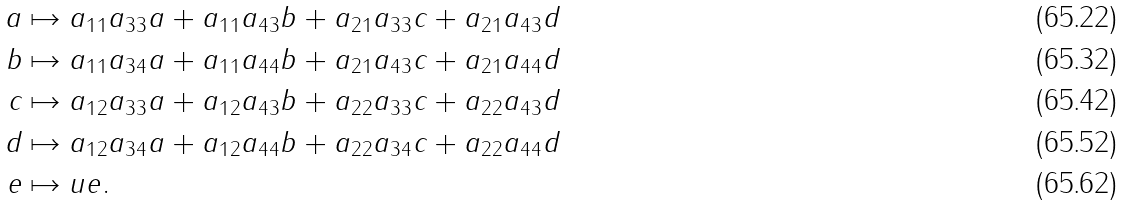<formula> <loc_0><loc_0><loc_500><loc_500>a & \mapsto a _ { 1 1 } a _ { 3 3 } a + a _ { 1 1 } a _ { 4 3 } b + a _ { 2 1 } a _ { 3 3 } c + a _ { 2 1 } a _ { 4 3 } d \\ b & \mapsto a _ { 1 1 } a _ { 3 4 } a + a _ { 1 1 } a _ { 4 4 } b + a _ { 2 1 } a _ { 4 3 } c + a _ { 2 1 } a _ { 4 4 } d \\ c & \mapsto a _ { 1 2 } a _ { 3 3 } a + a _ { 1 2 } a _ { 4 3 } b + a _ { 2 2 } a _ { 3 3 } c + a _ { 2 2 } a _ { 4 3 } d \\ d & \mapsto a _ { 1 2 } a _ { 3 4 } a + a _ { 1 2 } a _ { 4 4 } b + a _ { 2 2 } a _ { 3 4 } c + a _ { 2 2 } a _ { 4 4 } d \\ e & \mapsto u e .</formula> 